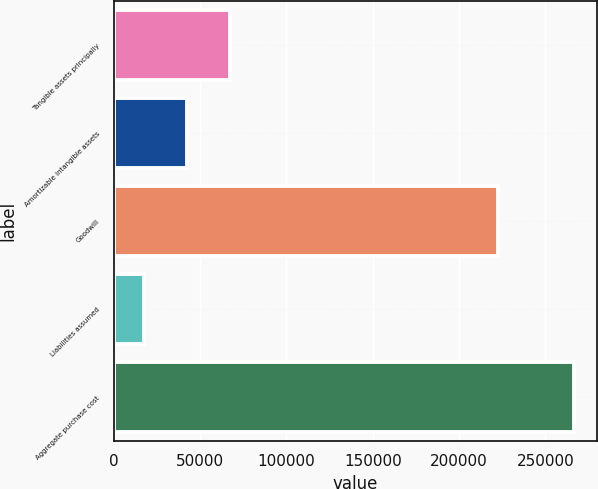Convert chart to OTSL. <chart><loc_0><loc_0><loc_500><loc_500><bar_chart><fcel>Tangible assets principally<fcel>Amortizable intangible assets<fcel>Goodwill<fcel>Liabilities assumed<fcel>Aggregate purchase cost<nl><fcel>67223.6<fcel>42289.8<fcel>222424<fcel>17356<fcel>266694<nl></chart> 